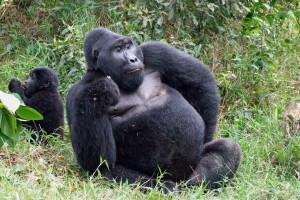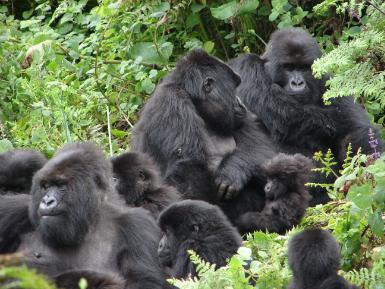The first image is the image on the left, the second image is the image on the right. Analyze the images presented: Is the assertion "Each image contains at least five gorillas, and at least one image shows a large forward-turned male standing on all fours in the front of the group." valid? Answer yes or no. No. 